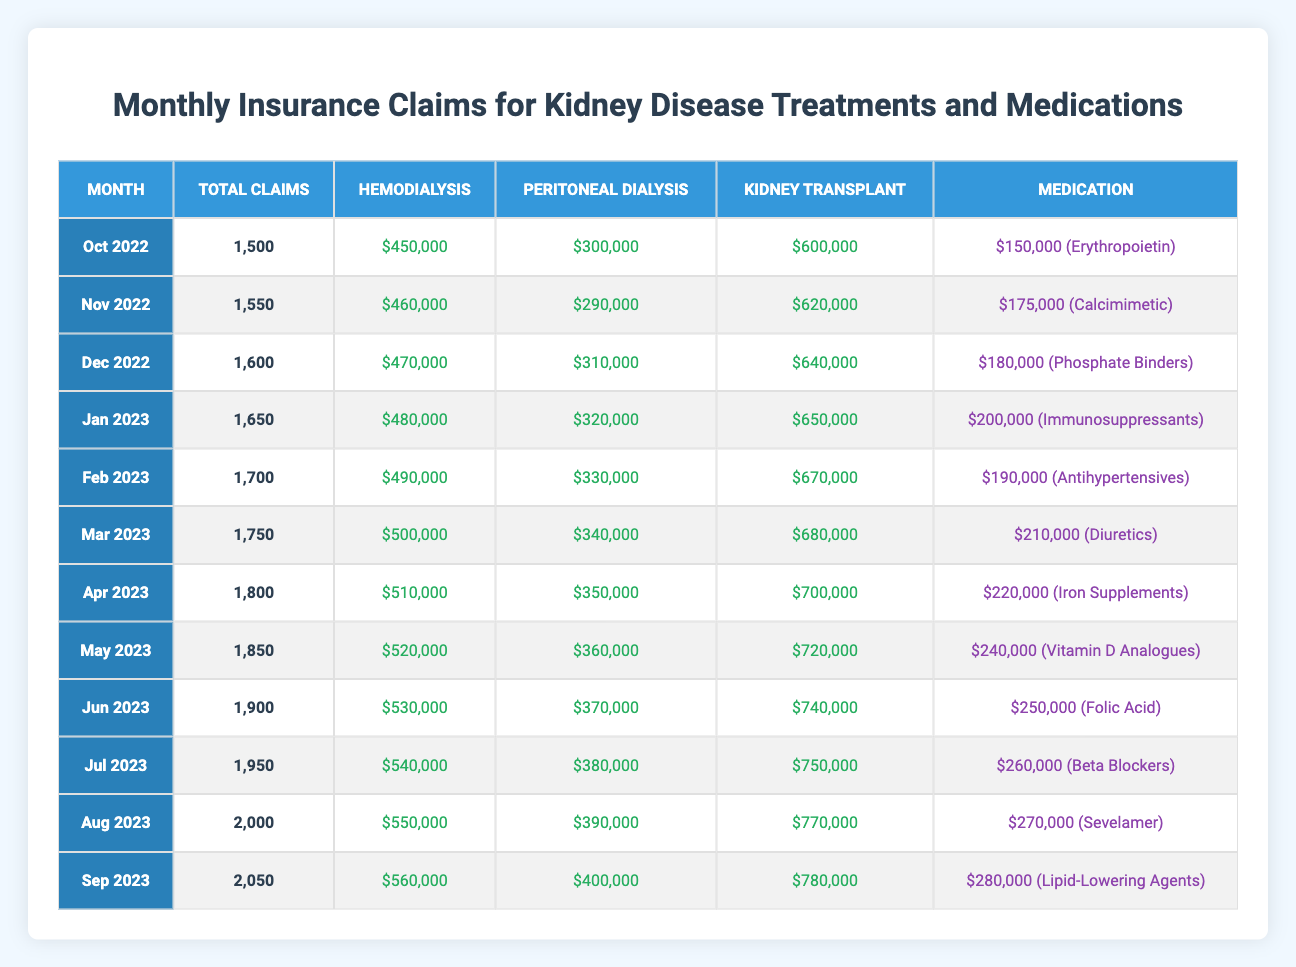What was the total number of claims in March 2023? In March 2023, the table shows the total claims as 1,750.
Answer: 1,750 Which treatment had the highest claim amount in September 2023? In September 2023, the claim amounts for each treatment show Hemodialysis at $560,000, Peritoneal Dialysis at $400,000, and Kidney Transplant at $780,000. The highest amount is for Kidney Transplant.
Answer: Kidney Transplant What is the difference in the total claims from October 2022 to September 2023? The total claims in October 2022 were 1,500 and in September 2023 were 2,050. The difference is 2,050 - 1,500 = 550.
Answer: 550 Did the amount for Peritoneal Dialysis increase every month from October 2022 to September 2023? Analyzing the table shows that the amounts for Peritoneal Dialysis were $300,000 in October 2022, and it increased each month until reaching $400,000 in September 2023. Thus, it did increase every month.
Answer: Yes What was the total claim amount for all treatments and medications in July 2023? The claims in July 2023 for each category are Hemodialysis at $540,000, Peritoneal Dialysis at $380,000, Kidney Transplant at $750,000, and medication (Beta Blockers) at $260,000. The total is 540,000 + 380,000 + 750,000 + 260,000 = 1,930,000.
Answer: $1,930,000 What is the average amount claimed for Hemodialysis from October 2022 to September 2023? The amounts for Hemodialysis are: $450,000, $460,000, $470,000, $480,000, $490,000, $500,000, $510,000, $520,000, $530,000, $540,000, $550,000, and $560,000. Summing these gives 5,700,000, divided by 12 months equals an average of 475,000.
Answer: $475,000 Which month had the highest total claim amount and what was it? The table indicates the highest total claim amount is in September 2023, which is 2,050.
Answer: September 2023, 2,050 Was there a claim for Immunosuppressants in the first six months of 2023? Looking at the table from January to June 2023 shows Immunosuppressants claimed only in January. There were no claims for this medication in the following months.
Answer: No What was the increase in the total claims from January 2023 to May 2023? In January 2023, total claims were 1,650, while in May 2023, they were 1,850. The increase is 1,850 - 1,650 = 200.
Answer: 200 